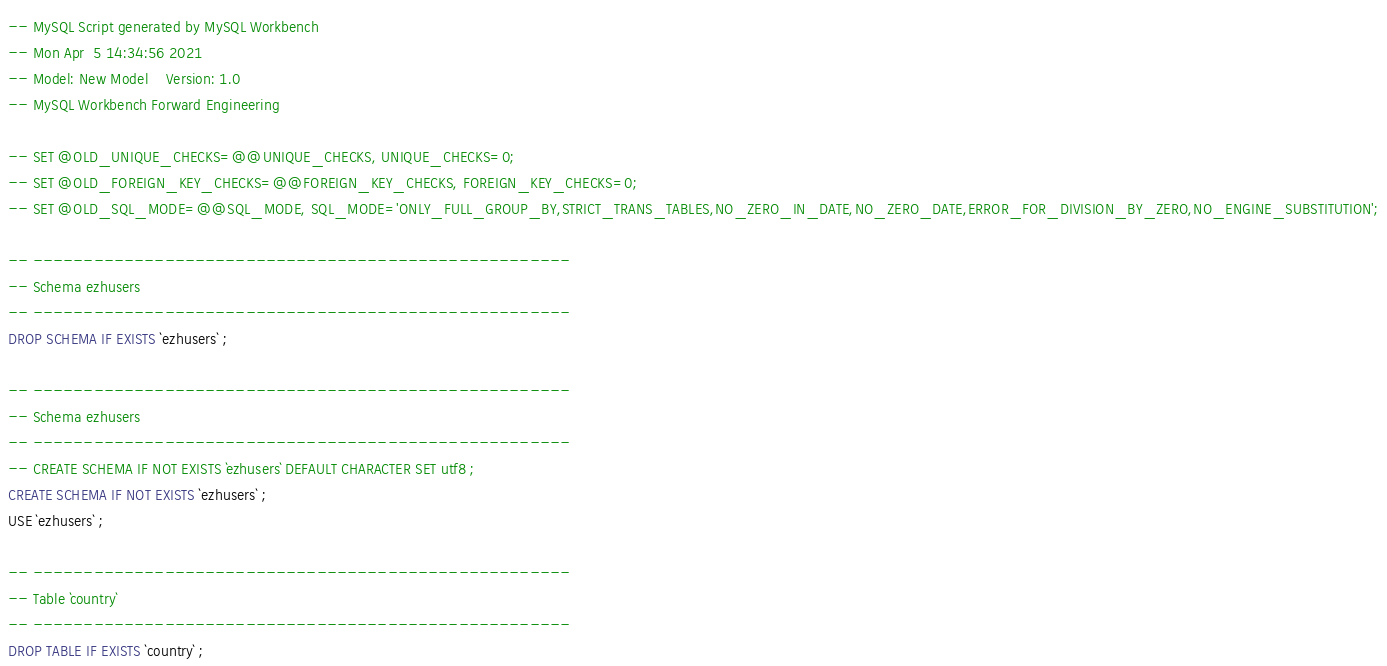Convert code to text. <code><loc_0><loc_0><loc_500><loc_500><_SQL_>-- MySQL Script generated by MySQL Workbench
-- Mon Apr  5 14:34:56 2021
-- Model: New Model    Version: 1.0
-- MySQL Workbench Forward Engineering

-- SET @OLD_UNIQUE_CHECKS=@@UNIQUE_CHECKS, UNIQUE_CHECKS=0;
-- SET @OLD_FOREIGN_KEY_CHECKS=@@FOREIGN_KEY_CHECKS, FOREIGN_KEY_CHECKS=0;
-- SET @OLD_SQL_MODE=@@SQL_MODE, SQL_MODE='ONLY_FULL_GROUP_BY,STRICT_TRANS_TABLES,NO_ZERO_IN_DATE,NO_ZERO_DATE,ERROR_FOR_DIVISION_BY_ZERO,NO_ENGINE_SUBSTITUTION';

-- -----------------------------------------------------
-- Schema ezhusers
-- -----------------------------------------------------
DROP SCHEMA IF EXISTS `ezhusers` ;

-- -----------------------------------------------------
-- Schema ezhusers
-- -----------------------------------------------------
-- CREATE SCHEMA IF NOT EXISTS `ezhusers` DEFAULT CHARACTER SET utf8 ;
CREATE SCHEMA IF NOT EXISTS `ezhusers` ;
USE `ezhusers` ;

-- -----------------------------------------------------
-- Table `country`
-- -----------------------------------------------------
DROP TABLE IF EXISTS `country` ;
</code> 